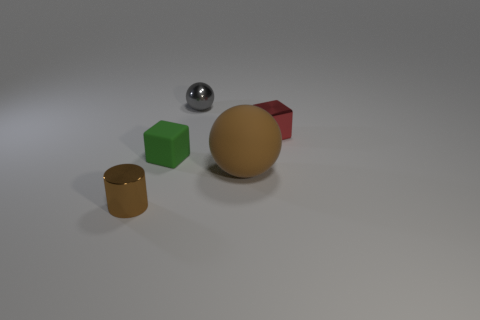Add 2 large yellow metal balls. How many objects exist? 7 Subtract all blocks. How many objects are left? 3 Add 2 brown matte balls. How many brown matte balls are left? 3 Add 3 big matte balls. How many big matte balls exist? 4 Subtract 0 gray cylinders. How many objects are left? 5 Subtract all big rubber things. Subtract all small cyan metal cylinders. How many objects are left? 4 